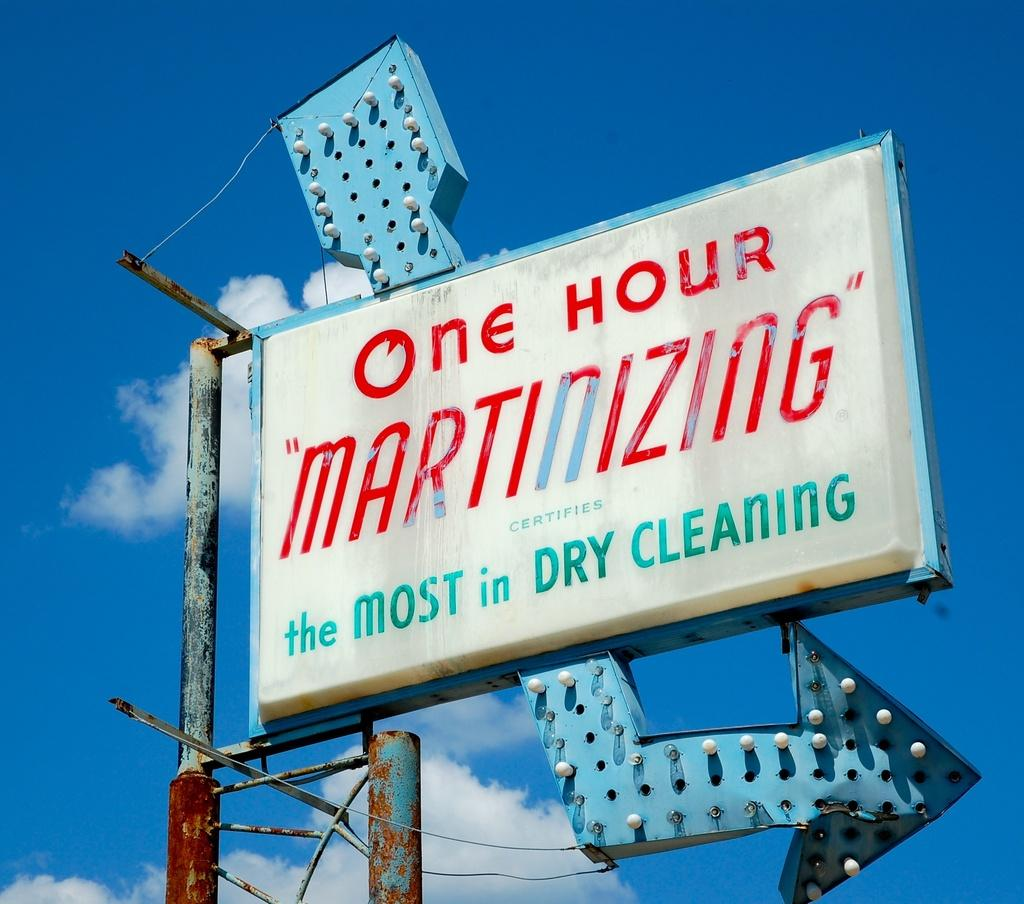<image>
Render a clear and concise summary of the photo. Store sign saying "One Hour Martinizing" hanging outdoors. 